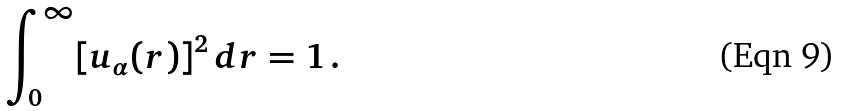<formula> <loc_0><loc_0><loc_500><loc_500>\int _ { 0 } ^ { \infty } [ u _ { \alpha } ( r ) ] ^ { 2 } \, d r = 1 \, .</formula> 